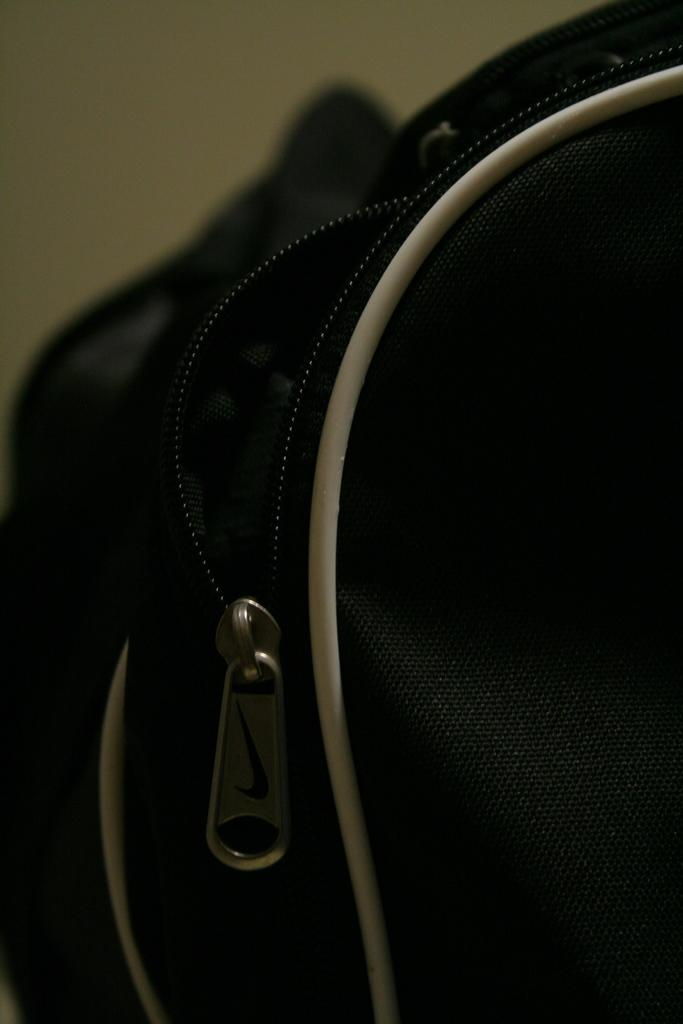What can be seen in the image related to a bag? There is a zip of a bag in the image. Can you see any deer near the edge of the quicksand in the image? There is no reference to quicksand or deer in the image; it only features the zip of a bag. 